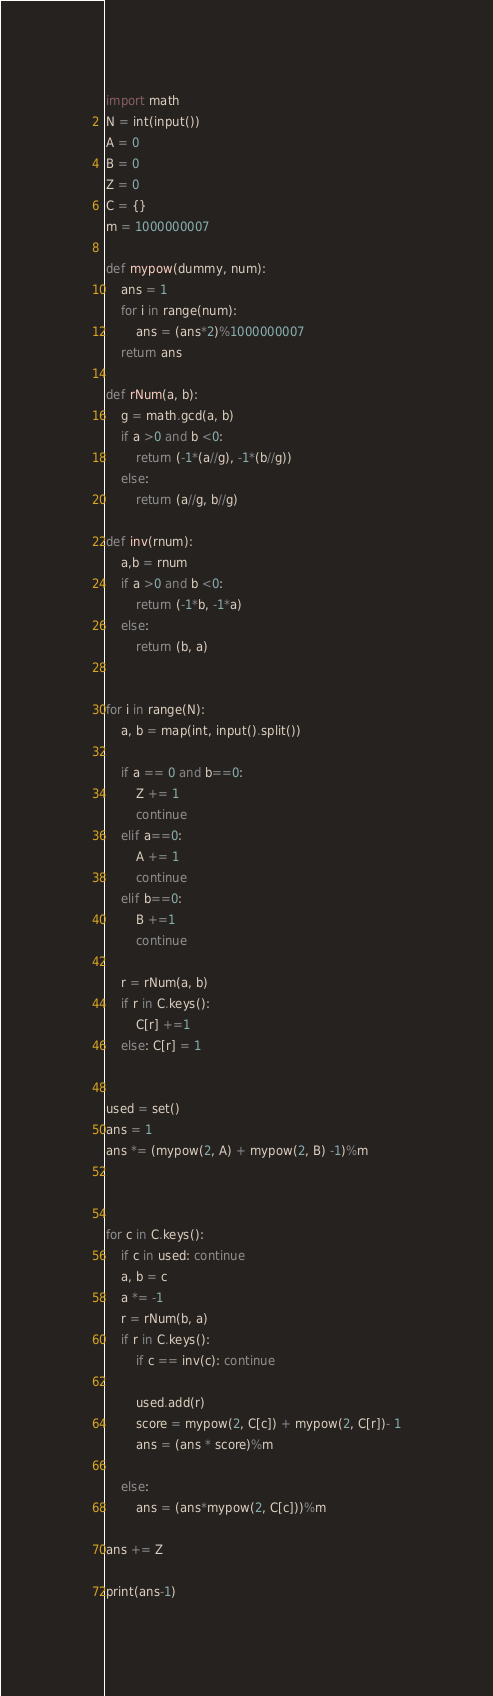Convert code to text. <code><loc_0><loc_0><loc_500><loc_500><_Python_>import math
N = int(input())
A = 0
B = 0
Z = 0
C = {}
m = 1000000007

def mypow(dummy, num):
    ans = 1
    for i in range(num):
        ans = (ans*2)%1000000007
    return ans

def rNum(a, b):
    g = math.gcd(a, b)
    if a >0 and b <0:
        return (-1*(a//g), -1*(b//g))
    else:
        return (a//g, b//g)

def inv(rnum):
    a,b = rnum
    if a >0 and b <0:
        return (-1*b, -1*a)
    else:
        return (b, a)
        

for i in range(N):
    a, b = map(int, input().split())
    
    if a == 0 and b==0:
        Z += 1
        continue
    elif a==0:
        A += 1
        continue
    elif b==0:
        B +=1
        continue
    
    r = rNum(a, b)
    if r in C.keys():
        C[r] +=1
    else: C[r] = 1


used = set()
ans = 1
ans *= (mypow(2, A) + mypow(2, B) -1)%m



for c in C.keys():
    if c in used: continue
    a, b = c
    a *= -1
    r = rNum(b, a)
    if r in C.keys():
        if c == inv(c): continue
        
        used.add(r)
        score = mypow(2, C[c]) + mypow(2, C[r])- 1
        ans = (ans * score)%m

    else:
        ans = (ans*mypow(2, C[c]))%m

ans += Z

print(ans-1)</code> 